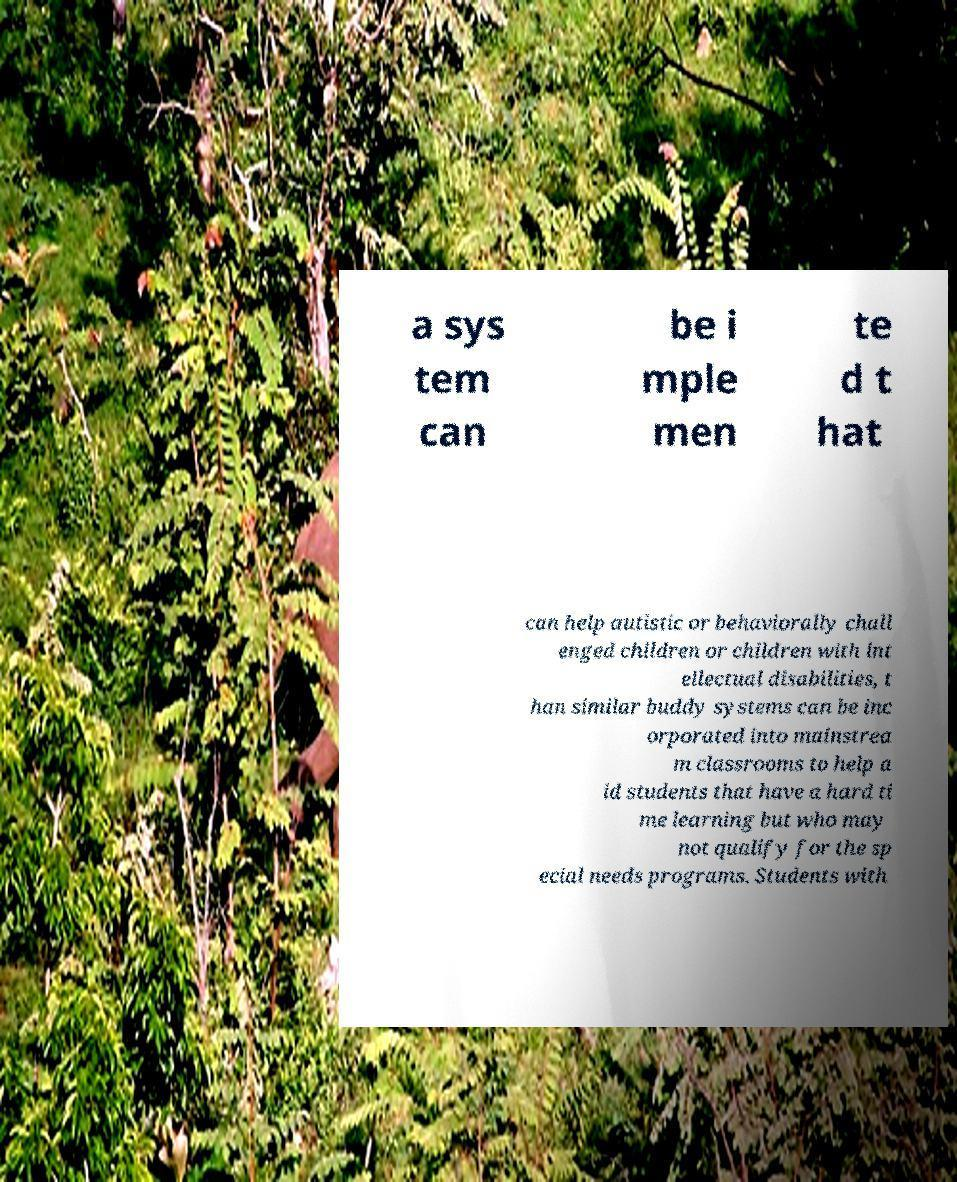I need the written content from this picture converted into text. Can you do that? a sys tem can be i mple men te d t hat can help autistic or behaviorally chall enged children or children with int ellectual disabilities, t han similar buddy systems can be inc orporated into mainstrea m classrooms to help a id students that have a hard ti me learning but who may not qualify for the sp ecial needs programs. Students with 